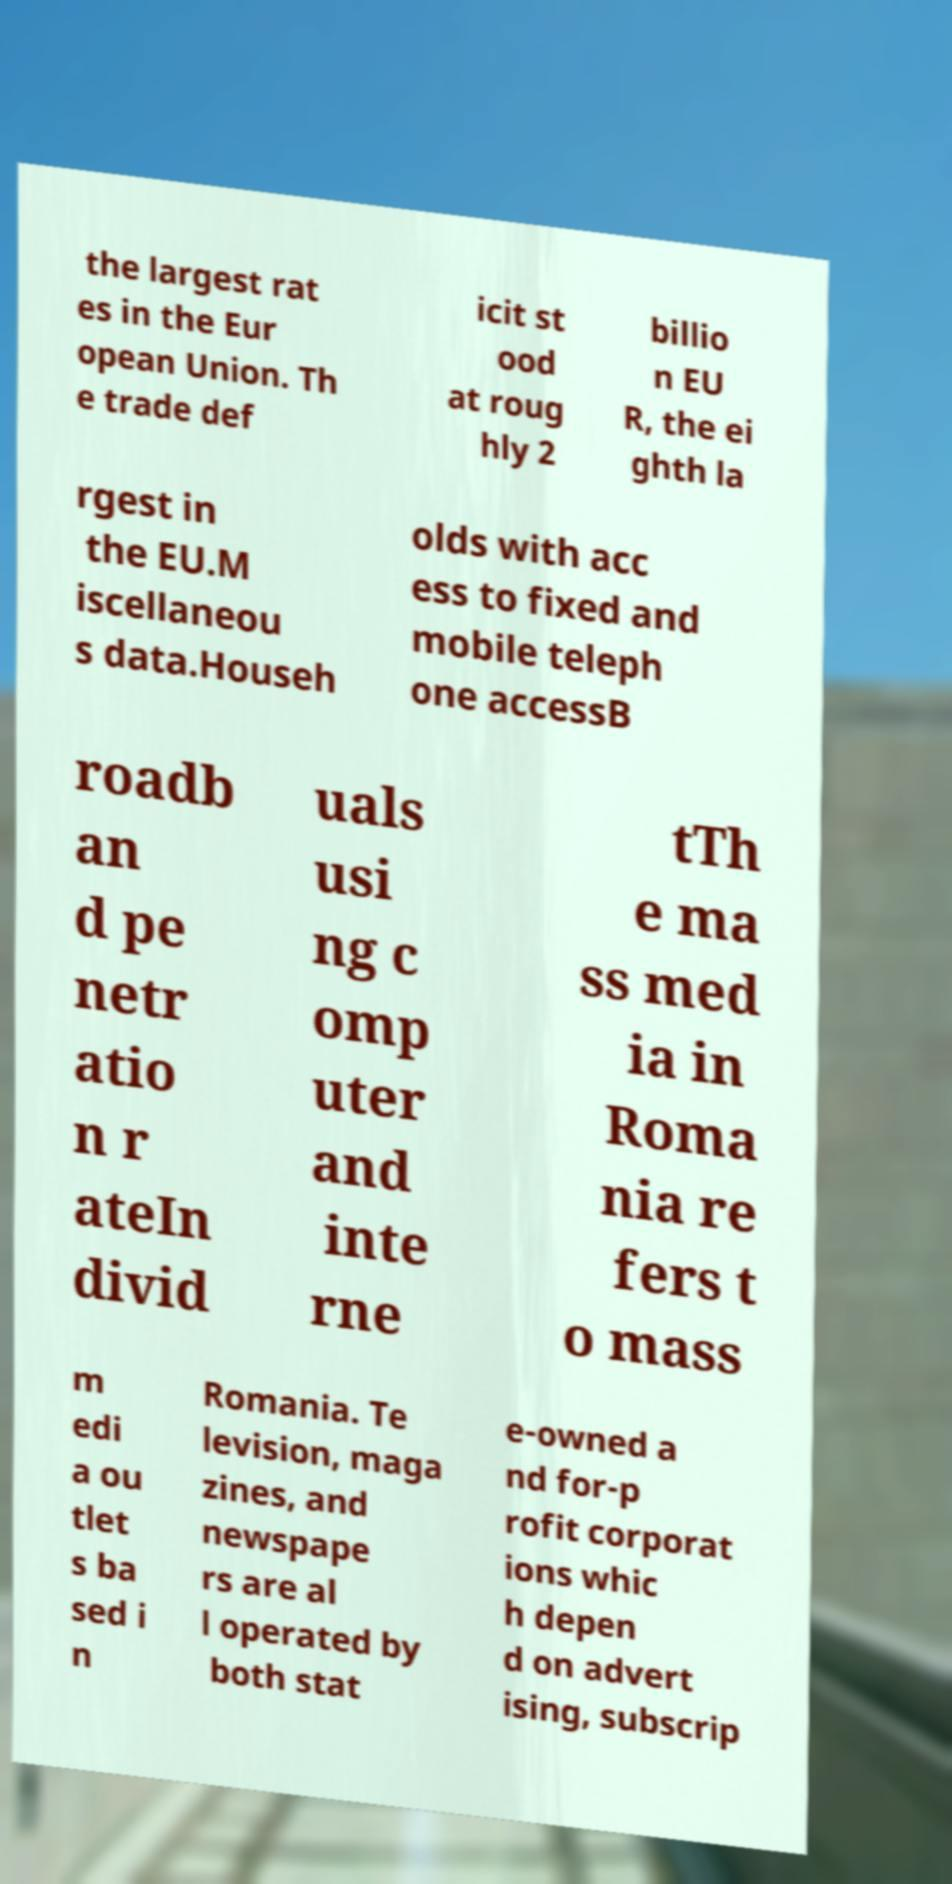What messages or text are displayed in this image? I need them in a readable, typed format. the largest rat es in the Eur opean Union. Th e trade def icit st ood at roug hly 2 billio n EU R, the ei ghth la rgest in the EU.M iscellaneou s data.Househ olds with acc ess to fixed and mobile teleph one accessB roadb an d pe netr atio n r ateIn divid uals usi ng c omp uter and inte rne tTh e ma ss med ia in Roma nia re fers t o mass m edi a ou tlet s ba sed i n Romania. Te levision, maga zines, and newspape rs are al l operated by both stat e-owned a nd for-p rofit corporat ions whic h depen d on advert ising, subscrip 